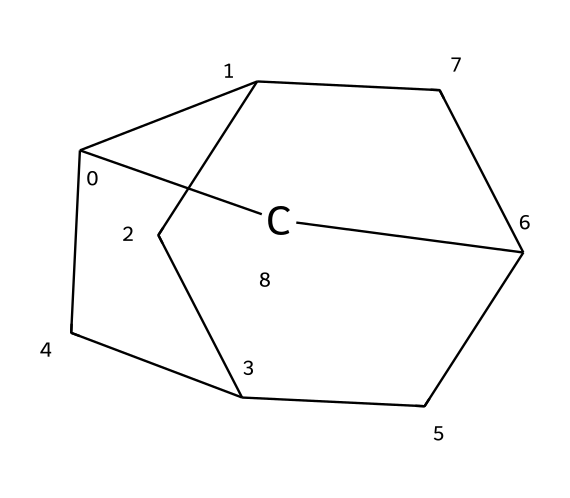How many carbon atoms are present in this compound? The SMILES representation indicates a structure with a formula derived based on the number of carbon (C) symbols. By analyzing the SMILES, there are a total of 10 carbon atoms present in the compound.
Answer: 10 What is the name of this compound? The provided SMILES corresponds to a well-known structure in organic chemistry, specifically, it represents adamantane, which is recognized for its unique cage-like configuration.
Answer: adamantane How many hydrogen atoms are associated with this compound? For cage compounds like adamantane, the general formula can give insight into hydrogen counts. Assuming each carbon is tetravalent and considering no functional groups are present, there are 16 hydrogen atoms linked to the 10 carbons based on typical saturation.
Answer: 16 What type of molecular geometry does adamantane possess? Examining the 3D symmetry and the tetrahedral arrangement of the carbon atoms in adamantane, it reveals a geometrical structure that resembles a diamond shape, due to its interconnected carbon framework.
Answer: tetrahedral Is adamantane a saturated or unsaturated compound? When observing the structure of adamantane, it is noted that all carbon-carbon bonds are single bonds, indicating that it does not contain any double or triple bonds, thus classifying it as a saturated compound.
Answer: saturated What is a characteristic feature of cage compounds like adamantane? Cage compounds typically possess a three-dimensional, closed network structure that allows them to enclose empty space or other atoms, giving them unique properties; adamantane is a prime example with its rigid, stable configuration of carbon atoms.
Answer: closed network structure How many unique carbon-carbon bond types are present in this compound? In the adamantane structure, all carbon-carbon bonds are single bonds due to its saturation, thus there is only one type of bond present in the entire cage structure.
Answer: 1 